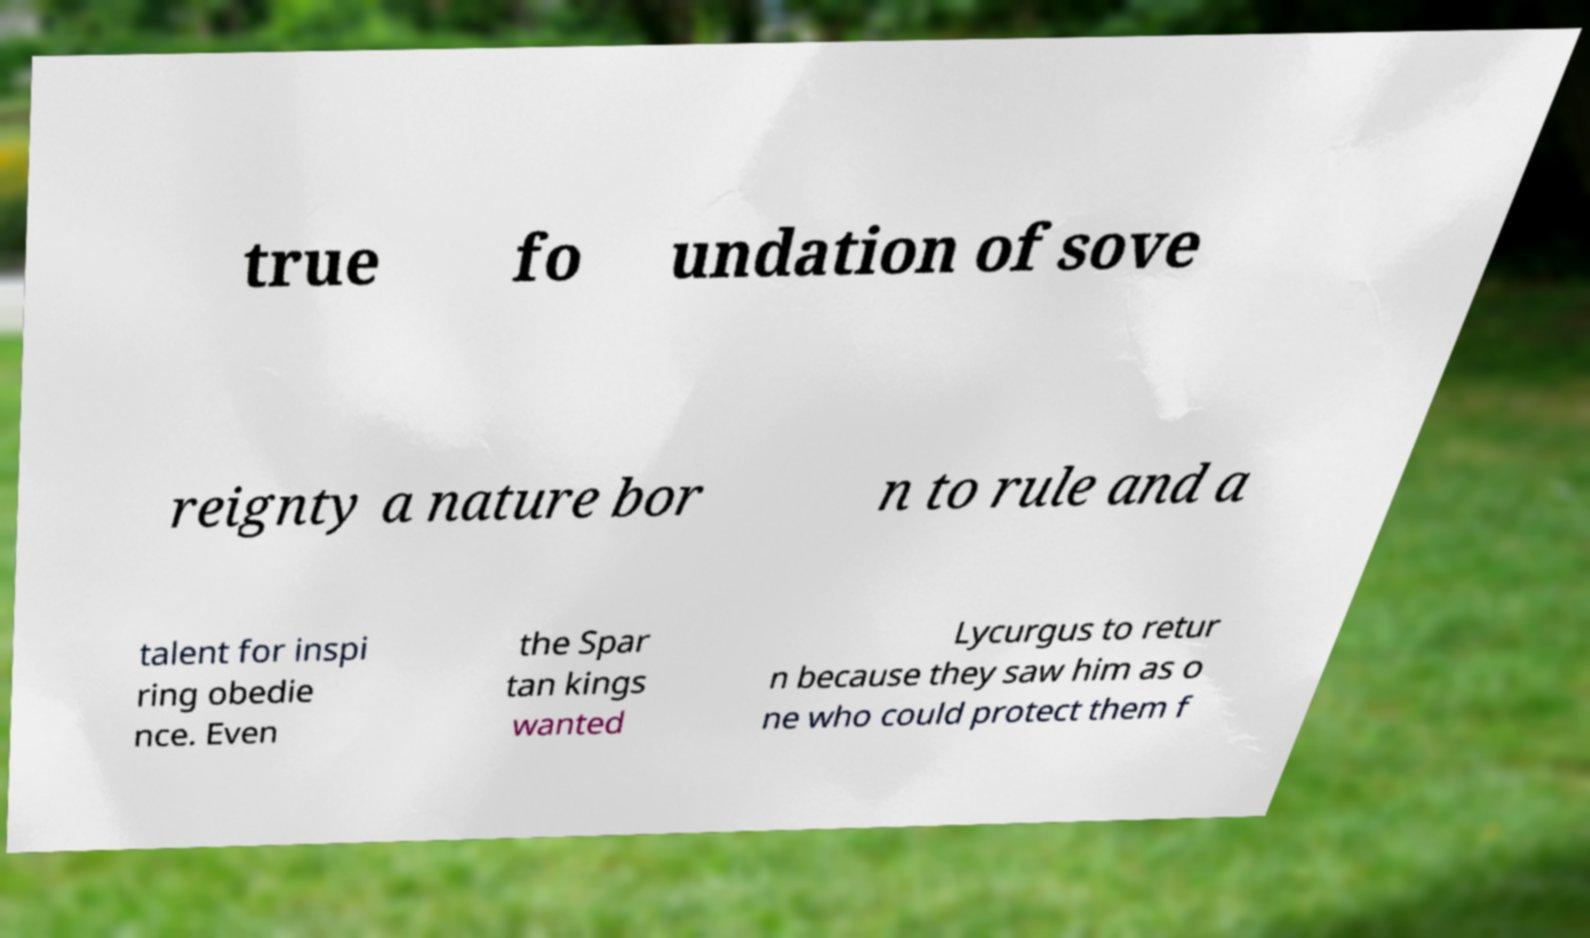There's text embedded in this image that I need extracted. Can you transcribe it verbatim? true fo undation of sove reignty a nature bor n to rule and a talent for inspi ring obedie nce. Even the Spar tan kings wanted Lycurgus to retur n because they saw him as o ne who could protect them f 